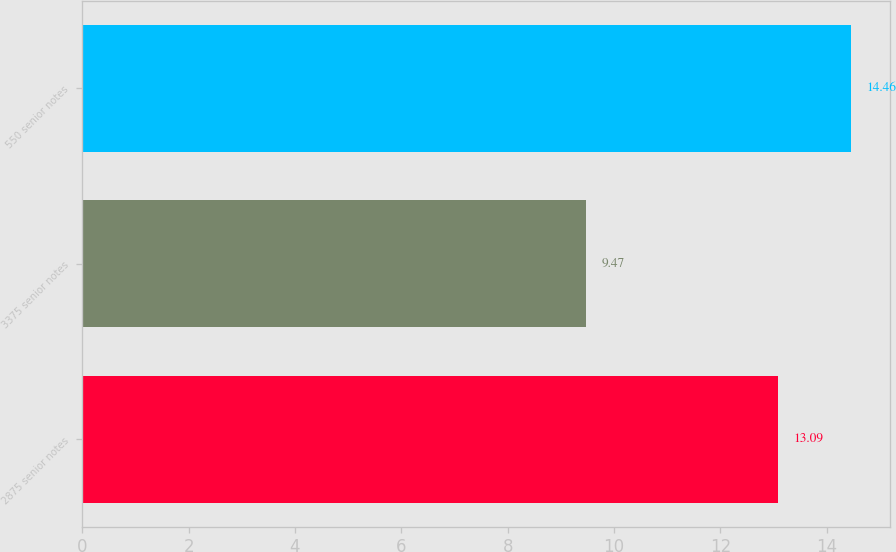<chart> <loc_0><loc_0><loc_500><loc_500><bar_chart><fcel>2875 senior notes<fcel>3375 senior notes<fcel>550 senior notes<nl><fcel>13.09<fcel>9.47<fcel>14.46<nl></chart> 